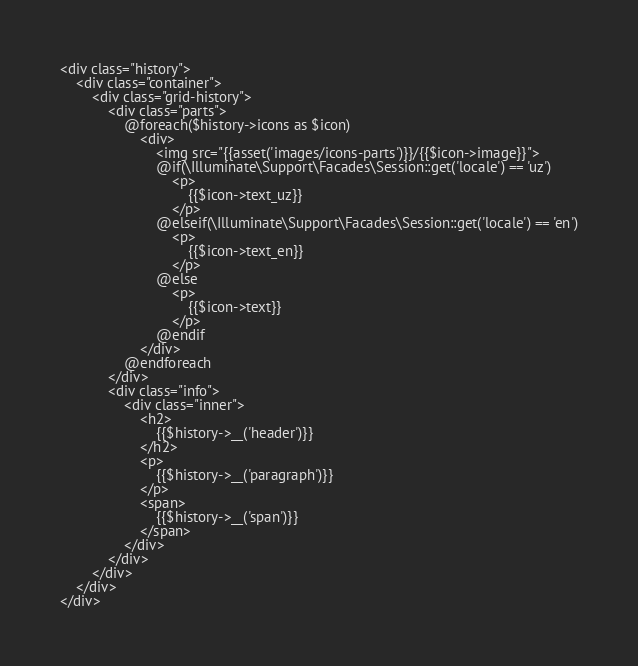Convert code to text. <code><loc_0><loc_0><loc_500><loc_500><_PHP_><div class="history">
    <div class="container">
        <div class="grid-history">
            <div class="parts">
                @foreach($history->icons as $icon)
                    <div>
                        <img src="{{asset('images/icons-parts')}}/{{$icon->image}}">
                        @if(\Illuminate\Support\Facades\Session::get('locale') == 'uz')
                            <p>
                                {{$icon->text_uz}}
                            </p>
                        @elseif(\Illuminate\Support\Facades\Session::get('locale') == 'en')
                            <p>
                                {{$icon->text_en}}
                            </p>
                        @else
                            <p>
                                {{$icon->text}}
                            </p>
                        @endif
                    </div>
                @endforeach
            </div>
            <div class="info">
                <div class="inner">
                    <h2>
                        {{$history->__('header')}}
                    </h2>
                    <p>
                        {{$history->__('paragraph')}}
                    </p>
                    <span>
						{{$history->__('span')}}
					</span>
                </div>
            </div>
        </div>
    </div>
</div>
</code> 